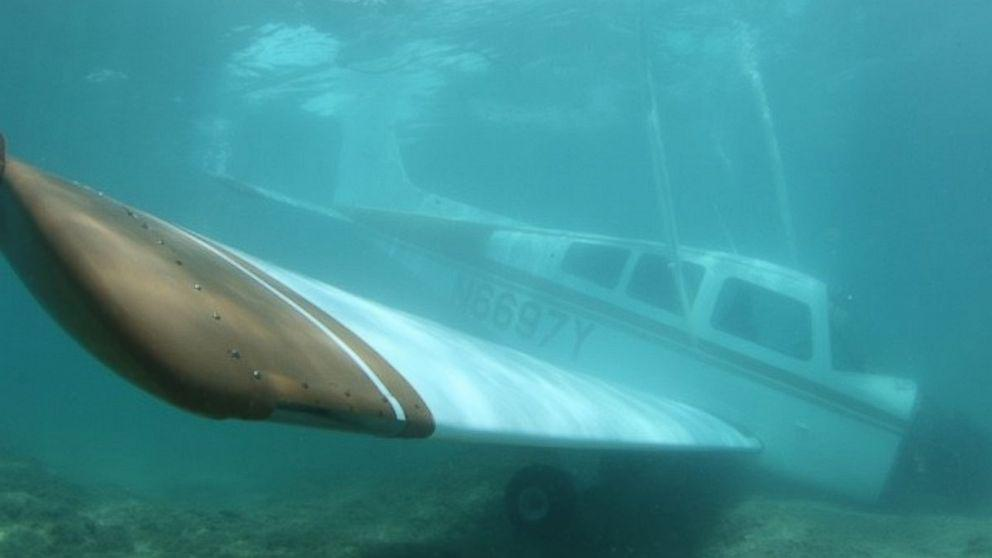What might have caused this airplane to be underwater? In this scenario, there could be a few possible explanations for the underwater airplane. One possibility is that it's part of a purposeful effort to create an artificial reef, which can enhance marine life habitat. Another possibility could be an accident, such as an emergency water landing. It is also possible that the plane was deliberately sunk for training divers or as an underwater attraction for tourists. 